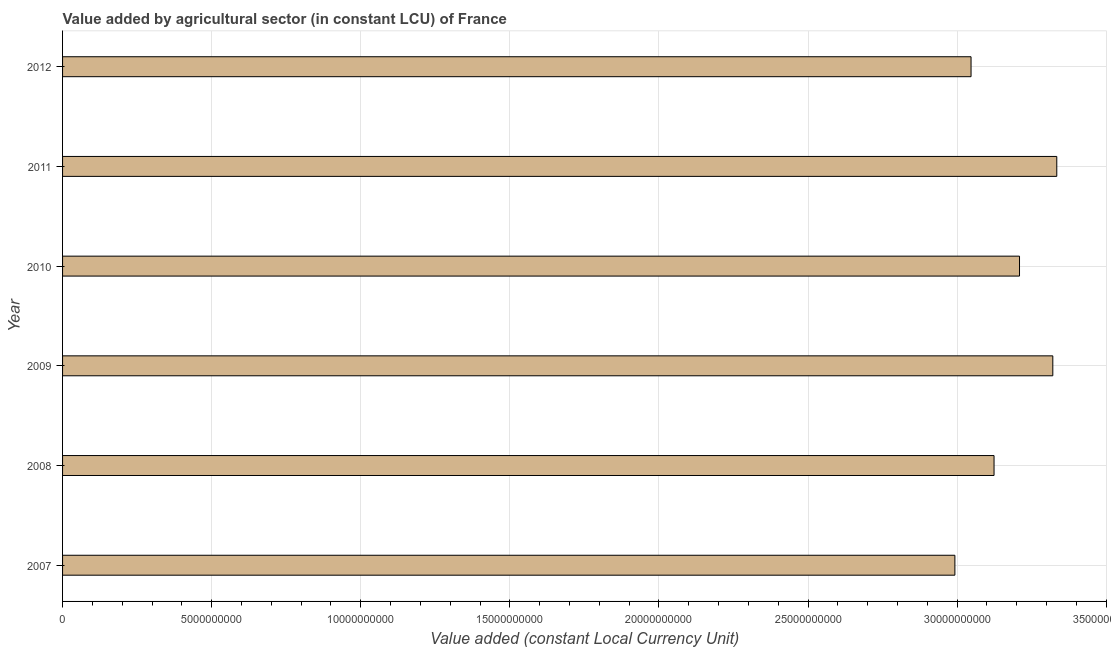What is the title of the graph?
Your answer should be very brief. Value added by agricultural sector (in constant LCU) of France. What is the label or title of the X-axis?
Your response must be concise. Value added (constant Local Currency Unit). What is the value added by agriculture sector in 2012?
Keep it short and to the point. 3.05e+1. Across all years, what is the maximum value added by agriculture sector?
Give a very brief answer. 3.33e+1. Across all years, what is the minimum value added by agriculture sector?
Keep it short and to the point. 2.99e+1. In which year was the value added by agriculture sector maximum?
Offer a terse response. 2011. In which year was the value added by agriculture sector minimum?
Your answer should be compact. 2007. What is the sum of the value added by agriculture sector?
Your answer should be very brief. 1.90e+11. What is the difference between the value added by agriculture sector in 2007 and 2011?
Provide a short and direct response. -3.42e+09. What is the average value added by agriculture sector per year?
Make the answer very short. 3.17e+1. What is the median value added by agriculture sector?
Keep it short and to the point. 3.17e+1. What is the ratio of the value added by agriculture sector in 2007 to that in 2009?
Provide a short and direct response. 0.9. Is the value added by agriculture sector in 2008 less than that in 2010?
Your answer should be compact. Yes. What is the difference between the highest and the second highest value added by agriculture sector?
Give a very brief answer. 1.33e+08. Is the sum of the value added by agriculture sector in 2009 and 2011 greater than the maximum value added by agriculture sector across all years?
Provide a short and direct response. Yes. What is the difference between the highest and the lowest value added by agriculture sector?
Ensure brevity in your answer.  3.42e+09. How many bars are there?
Your response must be concise. 6. How many years are there in the graph?
Your answer should be compact. 6. What is the difference between two consecutive major ticks on the X-axis?
Offer a very short reply. 5.00e+09. Are the values on the major ticks of X-axis written in scientific E-notation?
Offer a very short reply. No. What is the Value added (constant Local Currency Unit) of 2007?
Provide a succinct answer. 2.99e+1. What is the Value added (constant Local Currency Unit) of 2008?
Offer a very short reply. 3.12e+1. What is the Value added (constant Local Currency Unit) in 2009?
Your answer should be very brief. 3.32e+1. What is the Value added (constant Local Currency Unit) in 2010?
Offer a terse response. 3.21e+1. What is the Value added (constant Local Currency Unit) of 2011?
Make the answer very short. 3.33e+1. What is the Value added (constant Local Currency Unit) of 2012?
Offer a very short reply. 3.05e+1. What is the difference between the Value added (constant Local Currency Unit) in 2007 and 2008?
Keep it short and to the point. -1.31e+09. What is the difference between the Value added (constant Local Currency Unit) in 2007 and 2009?
Make the answer very short. -3.28e+09. What is the difference between the Value added (constant Local Currency Unit) in 2007 and 2010?
Offer a very short reply. -2.17e+09. What is the difference between the Value added (constant Local Currency Unit) in 2007 and 2011?
Offer a terse response. -3.42e+09. What is the difference between the Value added (constant Local Currency Unit) in 2007 and 2012?
Provide a succinct answer. -5.42e+08. What is the difference between the Value added (constant Local Currency Unit) in 2008 and 2009?
Provide a short and direct response. -1.97e+09. What is the difference between the Value added (constant Local Currency Unit) in 2008 and 2010?
Your response must be concise. -8.54e+08. What is the difference between the Value added (constant Local Currency Unit) in 2008 and 2011?
Ensure brevity in your answer.  -2.10e+09. What is the difference between the Value added (constant Local Currency Unit) in 2008 and 2012?
Provide a succinct answer. 7.71e+08. What is the difference between the Value added (constant Local Currency Unit) in 2009 and 2010?
Your answer should be very brief. 1.12e+09. What is the difference between the Value added (constant Local Currency Unit) in 2009 and 2011?
Your answer should be very brief. -1.33e+08. What is the difference between the Value added (constant Local Currency Unit) in 2009 and 2012?
Keep it short and to the point. 2.74e+09. What is the difference between the Value added (constant Local Currency Unit) in 2010 and 2011?
Make the answer very short. -1.25e+09. What is the difference between the Value added (constant Local Currency Unit) in 2010 and 2012?
Offer a very short reply. 1.62e+09. What is the difference between the Value added (constant Local Currency Unit) in 2011 and 2012?
Keep it short and to the point. 2.88e+09. What is the ratio of the Value added (constant Local Currency Unit) in 2007 to that in 2008?
Your answer should be very brief. 0.96. What is the ratio of the Value added (constant Local Currency Unit) in 2007 to that in 2009?
Your answer should be compact. 0.9. What is the ratio of the Value added (constant Local Currency Unit) in 2007 to that in 2010?
Ensure brevity in your answer.  0.93. What is the ratio of the Value added (constant Local Currency Unit) in 2007 to that in 2011?
Ensure brevity in your answer.  0.9. What is the ratio of the Value added (constant Local Currency Unit) in 2008 to that in 2009?
Your answer should be compact. 0.94. What is the ratio of the Value added (constant Local Currency Unit) in 2008 to that in 2010?
Keep it short and to the point. 0.97. What is the ratio of the Value added (constant Local Currency Unit) in 2008 to that in 2011?
Provide a short and direct response. 0.94. What is the ratio of the Value added (constant Local Currency Unit) in 2008 to that in 2012?
Make the answer very short. 1.02. What is the ratio of the Value added (constant Local Currency Unit) in 2009 to that in 2010?
Your answer should be compact. 1.03. What is the ratio of the Value added (constant Local Currency Unit) in 2009 to that in 2011?
Your answer should be compact. 1. What is the ratio of the Value added (constant Local Currency Unit) in 2009 to that in 2012?
Your answer should be very brief. 1.09. What is the ratio of the Value added (constant Local Currency Unit) in 2010 to that in 2012?
Keep it short and to the point. 1.05. What is the ratio of the Value added (constant Local Currency Unit) in 2011 to that in 2012?
Provide a succinct answer. 1.09. 